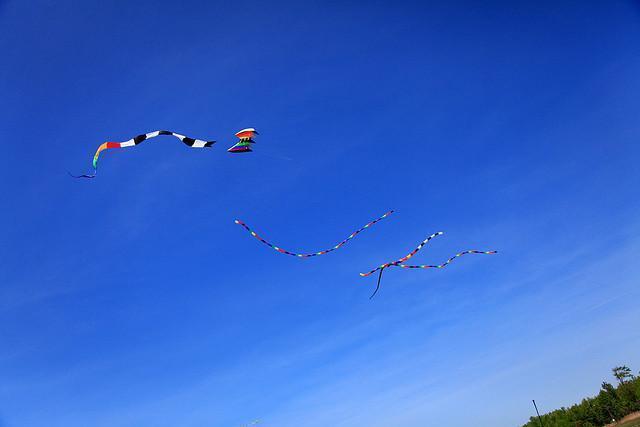How many people are distracted by their smartphone?
Give a very brief answer. 0. 